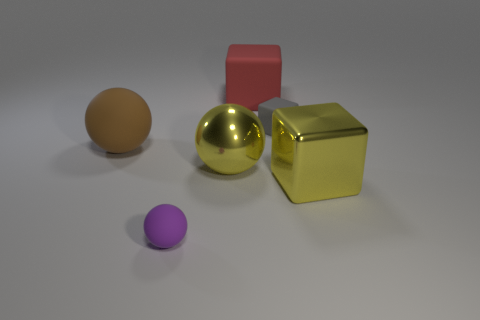What is the material of the brown thing that is the same shape as the tiny purple rubber thing?
Make the answer very short. Rubber. What number of large yellow shiny objects have the same shape as the brown matte object?
Your answer should be compact. 1. There is a thing that is the same color as the big metal cube; what is its shape?
Offer a terse response. Sphere. Are there more small gray cubes that are right of the yellow block than large yellow metal things?
Keep it short and to the point. No. What is the size of the gray block that is the same material as the red object?
Give a very brief answer. Small. Are there any yellow cubes behind the big red rubber object?
Give a very brief answer. No. Is the shape of the small gray object the same as the big brown thing?
Offer a terse response. No. There is a rubber thing that is in front of the large block that is in front of the yellow object that is to the left of the large red object; what size is it?
Give a very brief answer. Small. What is the tiny gray thing made of?
Your response must be concise. Rubber. What is the size of the metal block that is the same color as the large metallic sphere?
Provide a short and direct response. Large. 